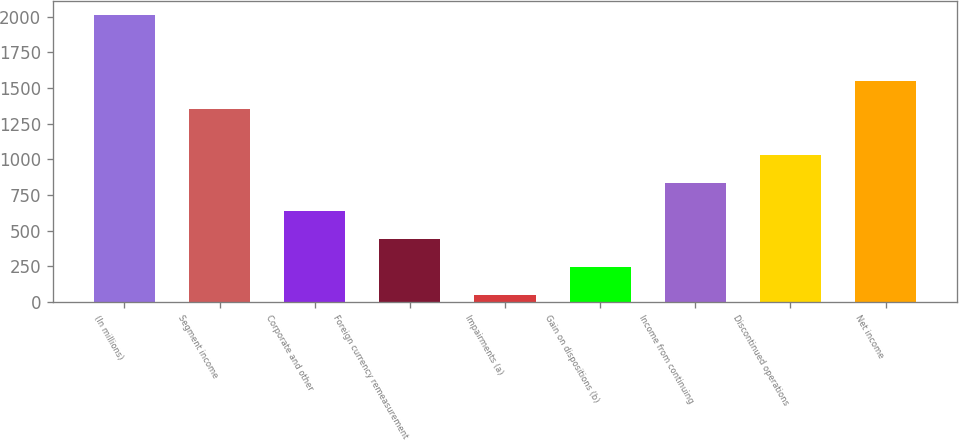<chart> <loc_0><loc_0><loc_500><loc_500><bar_chart><fcel>(In millions)<fcel>Segment income<fcel>Corporate and other<fcel>Foreign currency remeasurement<fcel>Impairments (a)<fcel>Gain on dispositions (b)<fcel>Income from continuing<fcel>Discontinued operations<fcel>Net income<nl><fcel>2009<fcel>1352<fcel>634.2<fcel>437.8<fcel>45<fcel>241.4<fcel>830.6<fcel>1027<fcel>1548.4<nl></chart> 